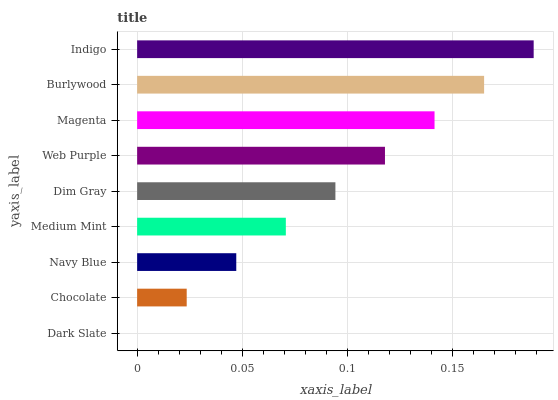Is Dark Slate the minimum?
Answer yes or no. Yes. Is Indigo the maximum?
Answer yes or no. Yes. Is Chocolate the minimum?
Answer yes or no. No. Is Chocolate the maximum?
Answer yes or no. No. Is Chocolate greater than Dark Slate?
Answer yes or no. Yes. Is Dark Slate less than Chocolate?
Answer yes or no. Yes. Is Dark Slate greater than Chocolate?
Answer yes or no. No. Is Chocolate less than Dark Slate?
Answer yes or no. No. Is Dim Gray the high median?
Answer yes or no. Yes. Is Dim Gray the low median?
Answer yes or no. Yes. Is Dark Slate the high median?
Answer yes or no. No. Is Navy Blue the low median?
Answer yes or no. No. 